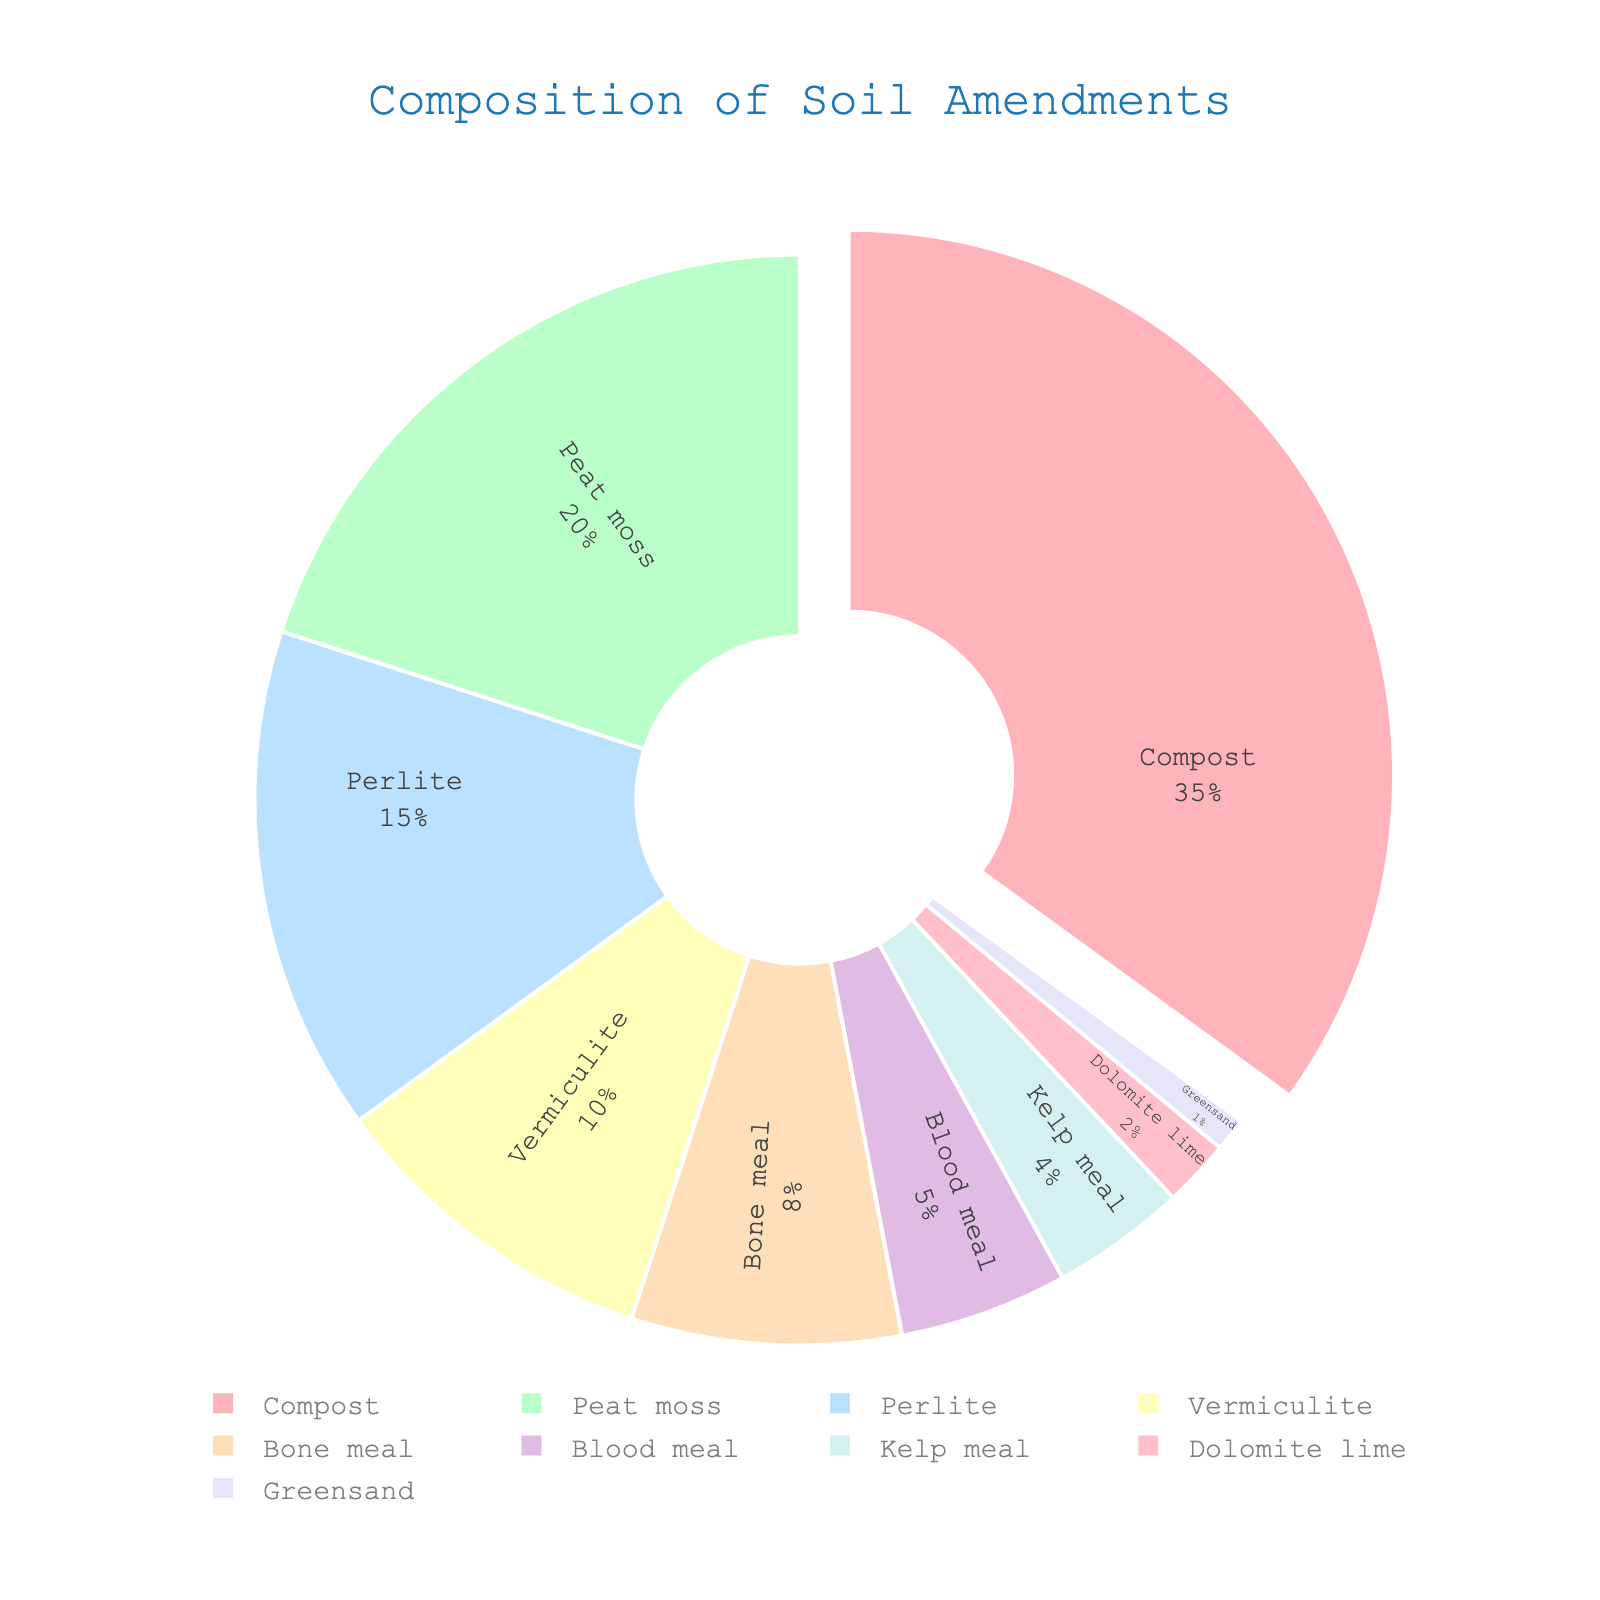What is the largest component in the soil amendments? The largest component can be identified by looking at the segment that has been pulled out slightly from the pie chart. This segment represents the highest percentage, which in this case is Compost at 35%.
Answer: Compost Which two components together make up 30% of the soil amendments? To find two components that together make up 30%, we can sum the percentages of different combinations. Peat moss is 20% and Perlite is 15%, exceeding 30%. However, Perlite at 15% and Vermiculite at 10% together make 25%, so we need another component. Blood Meal at 5% makes it a total of 30%.
Answer: Peat moss and Vermiculite Which component contributes only 1% to the soil amendments? By looking at the segment corresponding to the smallest percentage, we can see that Greensand is the component that makes up 1% of the soil amendments.
Answer: Greensand How do Perlite and Blood Meal compare in terms of percentage? Comparative analysis involves looking at the percentage values of Perlite and Blood Meal. Perlite contributes 15% while Blood Meal contributes 5%. Clearly, Perlite has a higher percentage.
Answer: Perlite has a higher percentage What is the combined percentage of all components contributing less than 10%? We add the percentages of components that contribute less than 10%: Vermiculite (10%) + Bone meal (8%) + Blood meal (5%) + Kelp meal (4%) + Dolomite lime (2%) + Greensand (1%) = 30%.
Answer: 30% What is the second most used component? By examining the pie chart, we observe that the largest component is Compost at 35%, followed by Peat moss at 20%. Hence, Peat moss is the second most used component.
Answer: Peat moss Which components have a contribution percentage difference of 5% or less? We need to identify components whose percentage differences are within 5%. Perlite (15%) and Vermiculite (10%), Bone meal (8%) and Blood meal (5%), and Dolomite lime (2%) and Greensand (1%), all fall within this range.
Answer: Perlite and Vermiculite; Bone meal and Blood meal; Dolomite lime and Greensand 